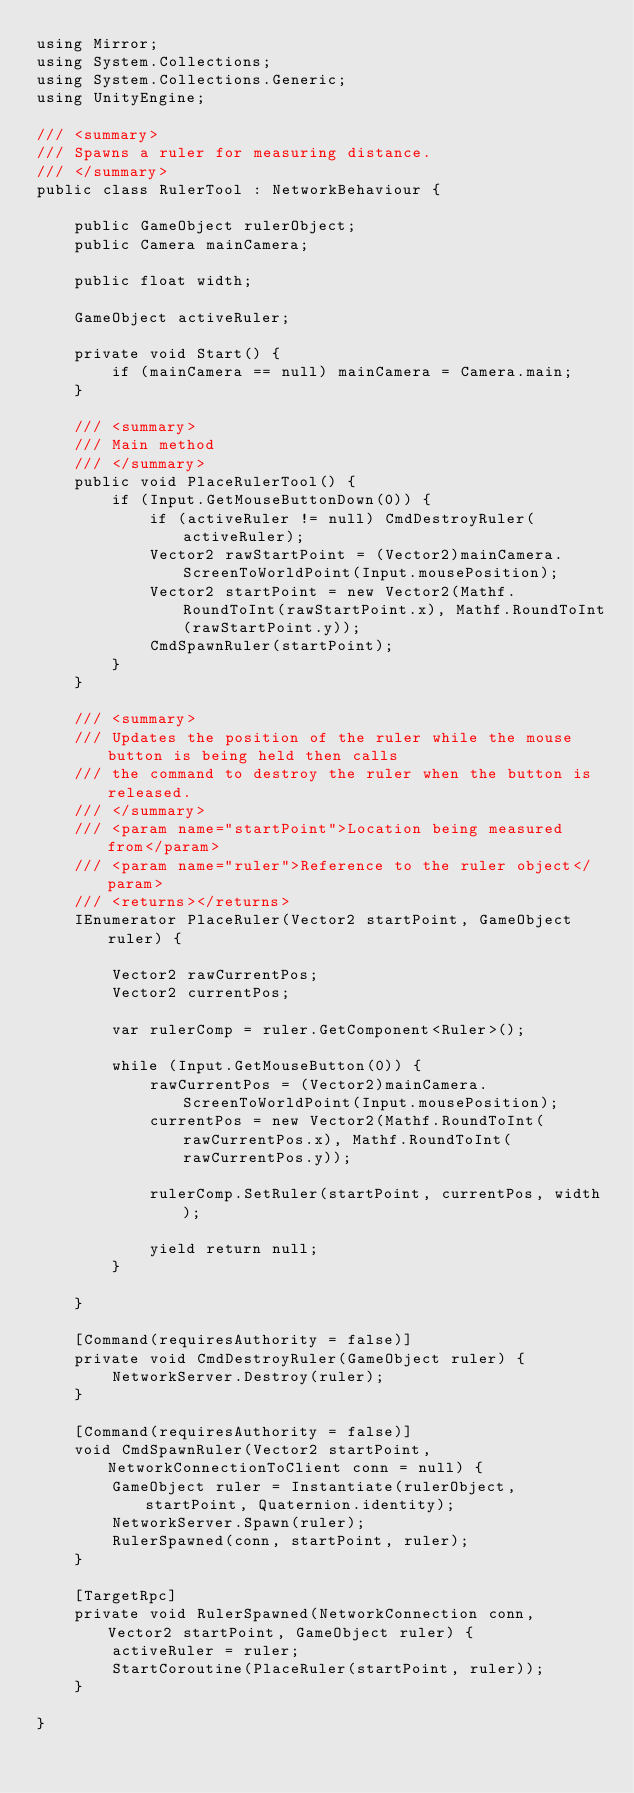Convert code to text. <code><loc_0><loc_0><loc_500><loc_500><_C#_>using Mirror;
using System.Collections;
using System.Collections.Generic;
using UnityEngine;

/// <summary>
/// Spawns a ruler for measuring distance.
/// </summary>
public class RulerTool : NetworkBehaviour {

    public GameObject rulerObject;
    public Camera mainCamera;

    public float width;

    GameObject activeRuler;

    private void Start() {
        if (mainCamera == null) mainCamera = Camera.main;
    }

    /// <summary>
    /// Main method
    /// </summary>
    public void PlaceRulerTool() {
        if (Input.GetMouseButtonDown(0)) {
            if (activeRuler != null) CmdDestroyRuler(activeRuler);
            Vector2 rawStartPoint = (Vector2)mainCamera.ScreenToWorldPoint(Input.mousePosition);
            Vector2 startPoint = new Vector2(Mathf.RoundToInt(rawStartPoint.x), Mathf.RoundToInt(rawStartPoint.y));
            CmdSpawnRuler(startPoint);
        }
    }

    /// <summary>
    /// Updates the position of the ruler while the mouse button is being held then calls
    /// the command to destroy the ruler when the button is released.
    /// </summary>
    /// <param name="startPoint">Location being measured from</param>
    /// <param name="ruler">Reference to the ruler object</param>
    /// <returns></returns>
    IEnumerator PlaceRuler(Vector2 startPoint, GameObject ruler) {

        Vector2 rawCurrentPos;
        Vector2 currentPos;

        var rulerComp = ruler.GetComponent<Ruler>();

        while (Input.GetMouseButton(0)) {
            rawCurrentPos = (Vector2)mainCamera.ScreenToWorldPoint(Input.mousePosition);
            currentPos = new Vector2(Mathf.RoundToInt(rawCurrentPos.x), Mathf.RoundToInt(rawCurrentPos.y));

            rulerComp.SetRuler(startPoint, currentPos, width);

            yield return null;
        }

    }

    [Command(requiresAuthority = false)]
    private void CmdDestroyRuler(GameObject ruler) {
        NetworkServer.Destroy(ruler);
    }

    [Command(requiresAuthority = false)]
    void CmdSpawnRuler(Vector2 startPoint, NetworkConnectionToClient conn = null) {
        GameObject ruler = Instantiate(rulerObject, startPoint, Quaternion.identity);
        NetworkServer.Spawn(ruler);
        RulerSpawned(conn, startPoint, ruler);
    }

    [TargetRpc]
    private void RulerSpawned(NetworkConnection conn, Vector2 startPoint, GameObject ruler) {
        activeRuler = ruler;
        StartCoroutine(PlaceRuler(startPoint, ruler));
    }

}

</code> 